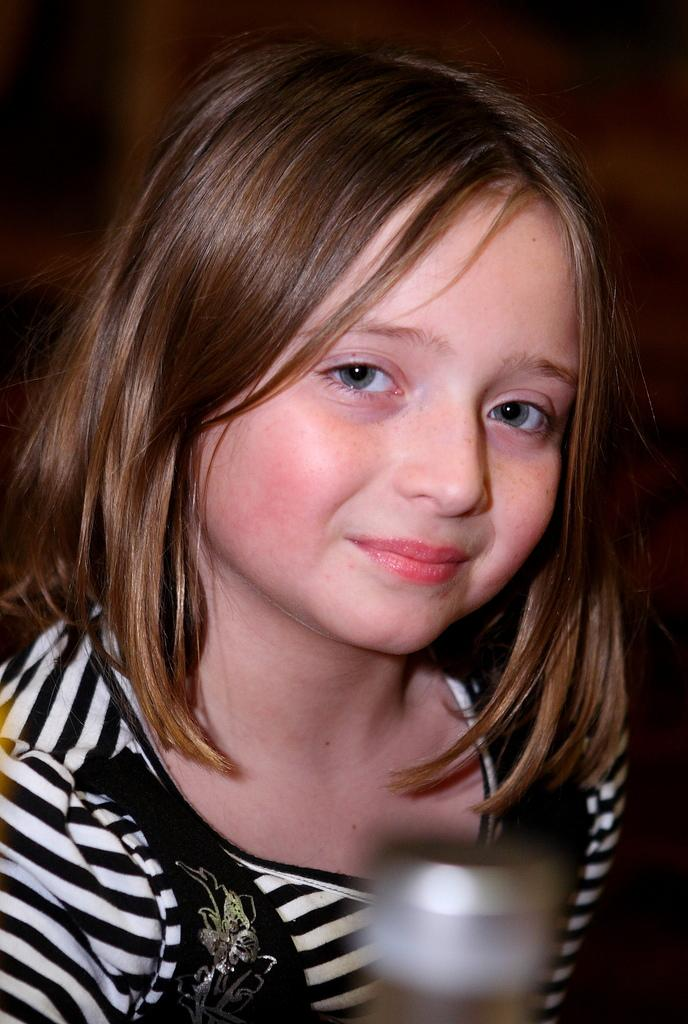Who is the main subject in the image? There is a girl in the image. What is the girl wearing? The girl is wearing a black and white dress. What is the girl's expression in the image? The girl is smiling. What can be observed about the background of the image? The background of the image is dark. How would you describe the quality of the image? The image is slightly blurred. What stage of development is the girl in the image? There is no information provided about the girl's stage of development in the image. What type of camera was used to take the image? There is no information provided about the camera used to take the image. 